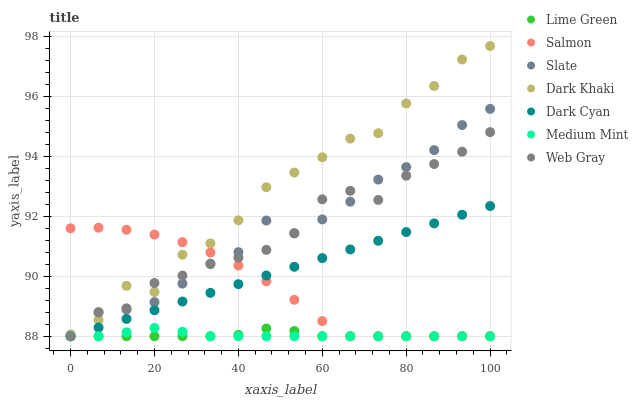Does Lime Green have the minimum area under the curve?
Answer yes or no. Yes. Does Dark Khaki have the maximum area under the curve?
Answer yes or no. Yes. Does Web Gray have the minimum area under the curve?
Answer yes or no. No. Does Web Gray have the maximum area under the curve?
Answer yes or no. No. Is Dark Cyan the smoothest?
Answer yes or no. Yes. Is Dark Khaki the roughest?
Answer yes or no. Yes. Is Web Gray the smoothest?
Answer yes or no. No. Is Web Gray the roughest?
Answer yes or no. No. Does Medium Mint have the lowest value?
Answer yes or no. Yes. Does Dark Khaki have the lowest value?
Answer yes or no. No. Does Dark Khaki have the highest value?
Answer yes or no. Yes. Does Web Gray have the highest value?
Answer yes or no. No. Is Dark Cyan less than Dark Khaki?
Answer yes or no. Yes. Is Dark Khaki greater than Medium Mint?
Answer yes or no. Yes. Does Medium Mint intersect Lime Green?
Answer yes or no. Yes. Is Medium Mint less than Lime Green?
Answer yes or no. No. Is Medium Mint greater than Lime Green?
Answer yes or no. No. Does Dark Cyan intersect Dark Khaki?
Answer yes or no. No. 